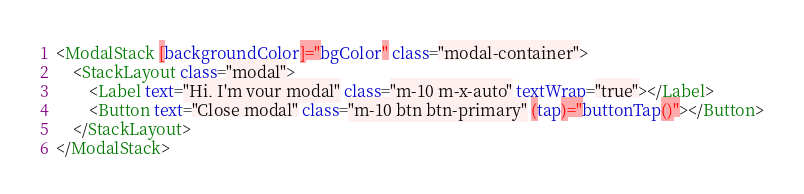Convert code to text. <code><loc_0><loc_0><loc_500><loc_500><_HTML_><ModalStack [backgroundColor]="bgColor" class="modal-container">
    <StackLayout class="modal">
        <Label text="Hi, I'm your modal" class="m-10 m-x-auto" textWrap="true"></Label>
        <Button text="Close modal" class="m-10 btn btn-primary" (tap)="buttonTap()"></Button>
    </StackLayout>
</ModalStack></code> 